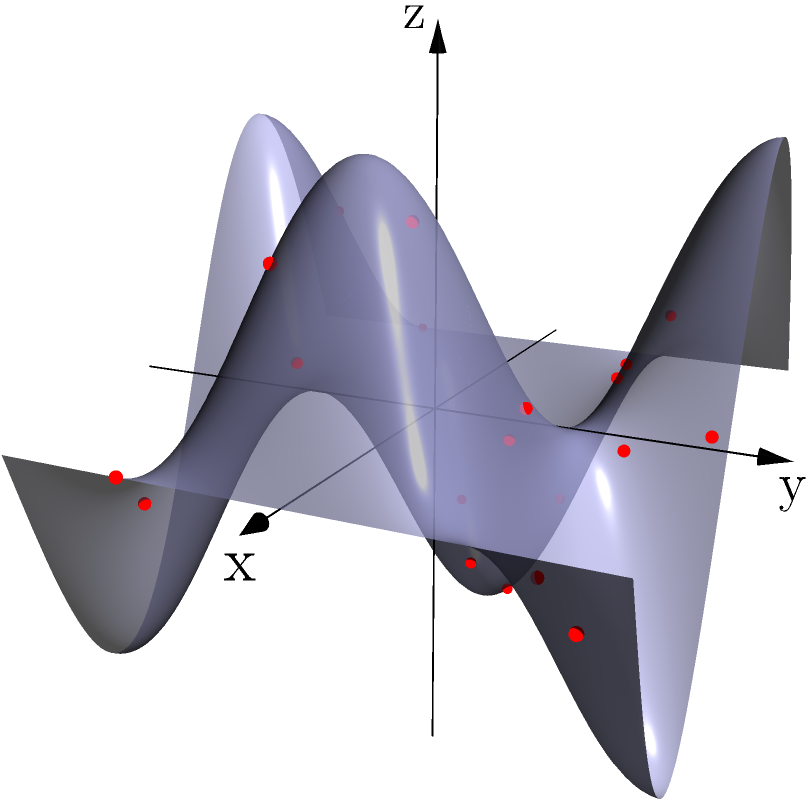In the context of creating a continuous surface from a set of 3D scan points for realistic object reconstruction in VFX, which interpolation method would be most suitable for generating a smooth surface that accurately represents the underlying geometry while minimizing artifacts? To answer this question, let's consider the following steps:

1. Understand the problem: We need to create a continuous surface from discrete 3D scan points, which is crucial for realistic object reconstruction in VFX.

2. Consider the requirements:
   a) Accuracy: The method should faithfully represent the underlying geometry.
   b) Smoothness: The resulting surface should be continuous and smooth.
   c) Artifact minimization: The method should avoid introducing unwanted artifacts.

3. Evaluate common interpolation methods:
   a) Linear interpolation: Simple but produces a faceted surface, not suitable for smooth objects.
   b) Nearest neighbor: Fast but results in a discontinuous surface.
   c) Polynomial interpolation: Can be smooth but prone to oscillations (Runge's phenomenon).
   d) Radial Basis Function (RBF): Good for scattered data but can be computationally expensive.
   e) Spline interpolation: Provides smooth results and is widely used in computer graphics.

4. Focus on spline interpolation:
   a) B-splines: Offer local control and are efficient to compute.
   b) NURBS (Non-Uniform Rational B-Splines): Extension of B-splines with additional flexibility.

5. Consider advanced techniques:
   a) Subdivision surfaces: Iteratively refine a coarse mesh to create smooth surfaces.
   b) Implicit surface reconstruction: Create a continuous implicit function that approximates the point cloud.

6. Evaluate the best option:
   NURBS (Non-Uniform Rational B-Splines) stand out as the most suitable method because:
   - They provide smooth, continuous surfaces.
   - They offer local control, allowing for accurate representation of complex geometries.
   - They are widely supported in VFX and 3D modeling software.
   - They minimize artifacts compared to simpler methods.
   - They are computationally efficient for real-time manipulation in VR environments.

Therefore, NURBS interpolation would be the most suitable method for this VFX application.
Answer: NURBS (Non-Uniform Rational B-Splines) 